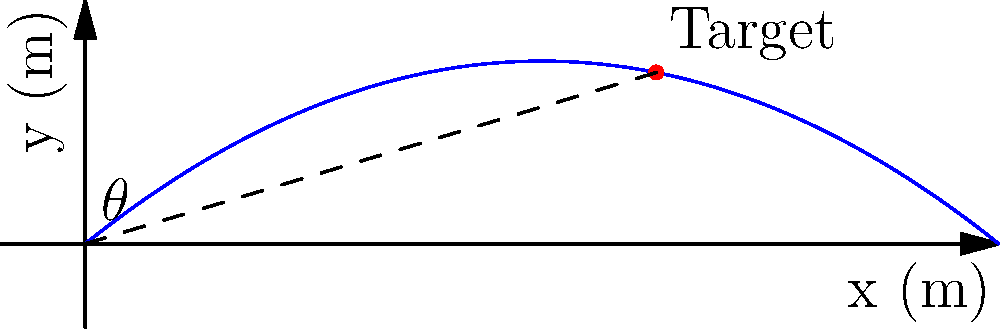A drone needs to be launched to reach a target located 10 meters horizontally and 3 meters vertically from the launch point. Using the coordinate system shown, determine the optimal launch angle $\theta$ (in degrees) for the drone to hit the target directly. Assume the drone's trajectory follows a parabolic path and neglect air resistance. To find the optimal launch angle, we can use trigonometry and the properties of a right triangle formed by the launch point, target, and the horizontal line.

Step 1: Identify the right triangle
The right triangle is formed by:
- Hypotenuse: Line from launch point (0,0) to target (10,3)
- Adjacent side: Horizontal distance (10 m)
- Opposite side: Vertical distance (3 m)

Step 2: Use the tangent function to calculate the angle
$\tan(\theta) = \frac{\text{opposite}}{\text{adjacent}} = \frac{3}{10}$

Step 3: Solve for $\theta$ using the inverse tangent (arctan) function
$\theta = \arctan(\frac{3}{10})$

Step 4: Convert the result to degrees
$\theta = \arctan(\frac{3}{10}) \cdot \frac{180}{\pi}$

Step 5: Calculate the final result
$\theta \approx 16.70^\circ$

Therefore, the optimal launch angle for the drone to hit the target directly is approximately 16.70 degrees.
Answer: $16.70^\circ$ 